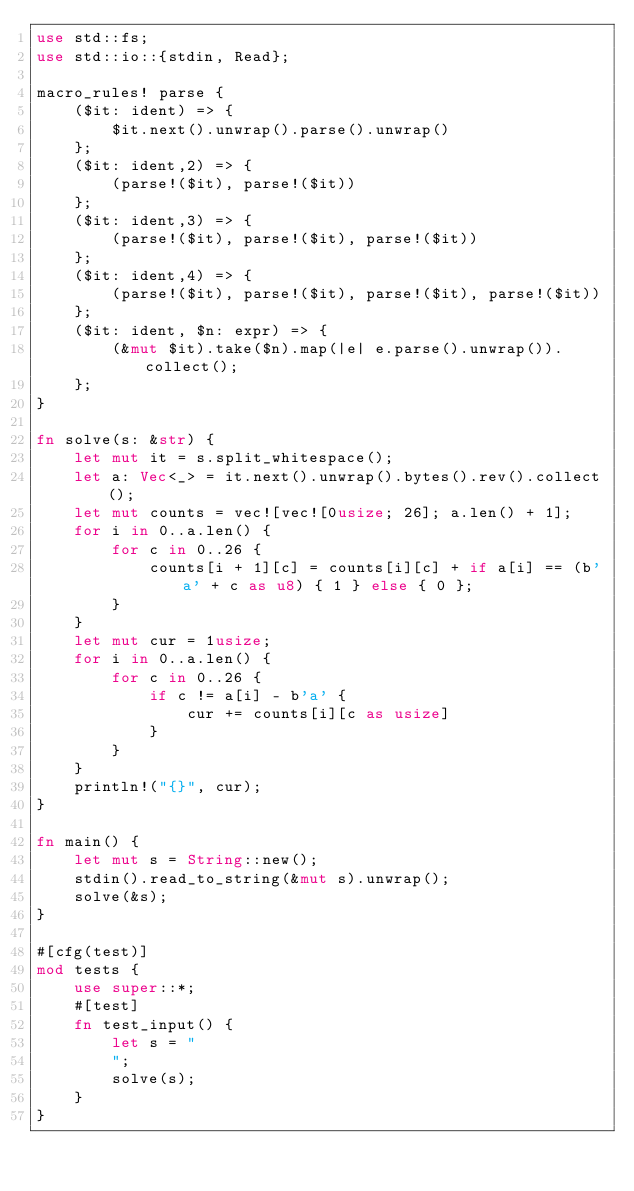<code> <loc_0><loc_0><loc_500><loc_500><_Rust_>use std::fs;
use std::io::{stdin, Read};

macro_rules! parse {
    ($it: ident) => {
        $it.next().unwrap().parse().unwrap()
    };
    ($it: ident,2) => {
        (parse!($it), parse!($it))
    };
    ($it: ident,3) => {
        (parse!($it), parse!($it), parse!($it))
    };
    ($it: ident,4) => {
        (parse!($it), parse!($it), parse!($it), parse!($it))
    };
    ($it: ident, $n: expr) => {
        (&mut $it).take($n).map(|e| e.parse().unwrap()).collect();
    };
}

fn solve(s: &str) {
    let mut it = s.split_whitespace();
    let a: Vec<_> = it.next().unwrap().bytes().rev().collect();
    let mut counts = vec![vec![0usize; 26]; a.len() + 1];
    for i in 0..a.len() {
        for c in 0..26 {
            counts[i + 1][c] = counts[i][c] + if a[i] == (b'a' + c as u8) { 1 } else { 0 };
        }
    }
    let mut cur = 1usize;
    for i in 0..a.len() {
        for c in 0..26 {
            if c != a[i] - b'a' {
                cur += counts[i][c as usize]
            }
        }
    }
    println!("{}", cur);
}

fn main() {
    let mut s = String::new();
    stdin().read_to_string(&mut s).unwrap();
    solve(&s);
}

#[cfg(test)]
mod tests {
    use super::*;
    #[test]
    fn test_input() {
        let s = "
        ";
        solve(s);
    }
}
</code> 